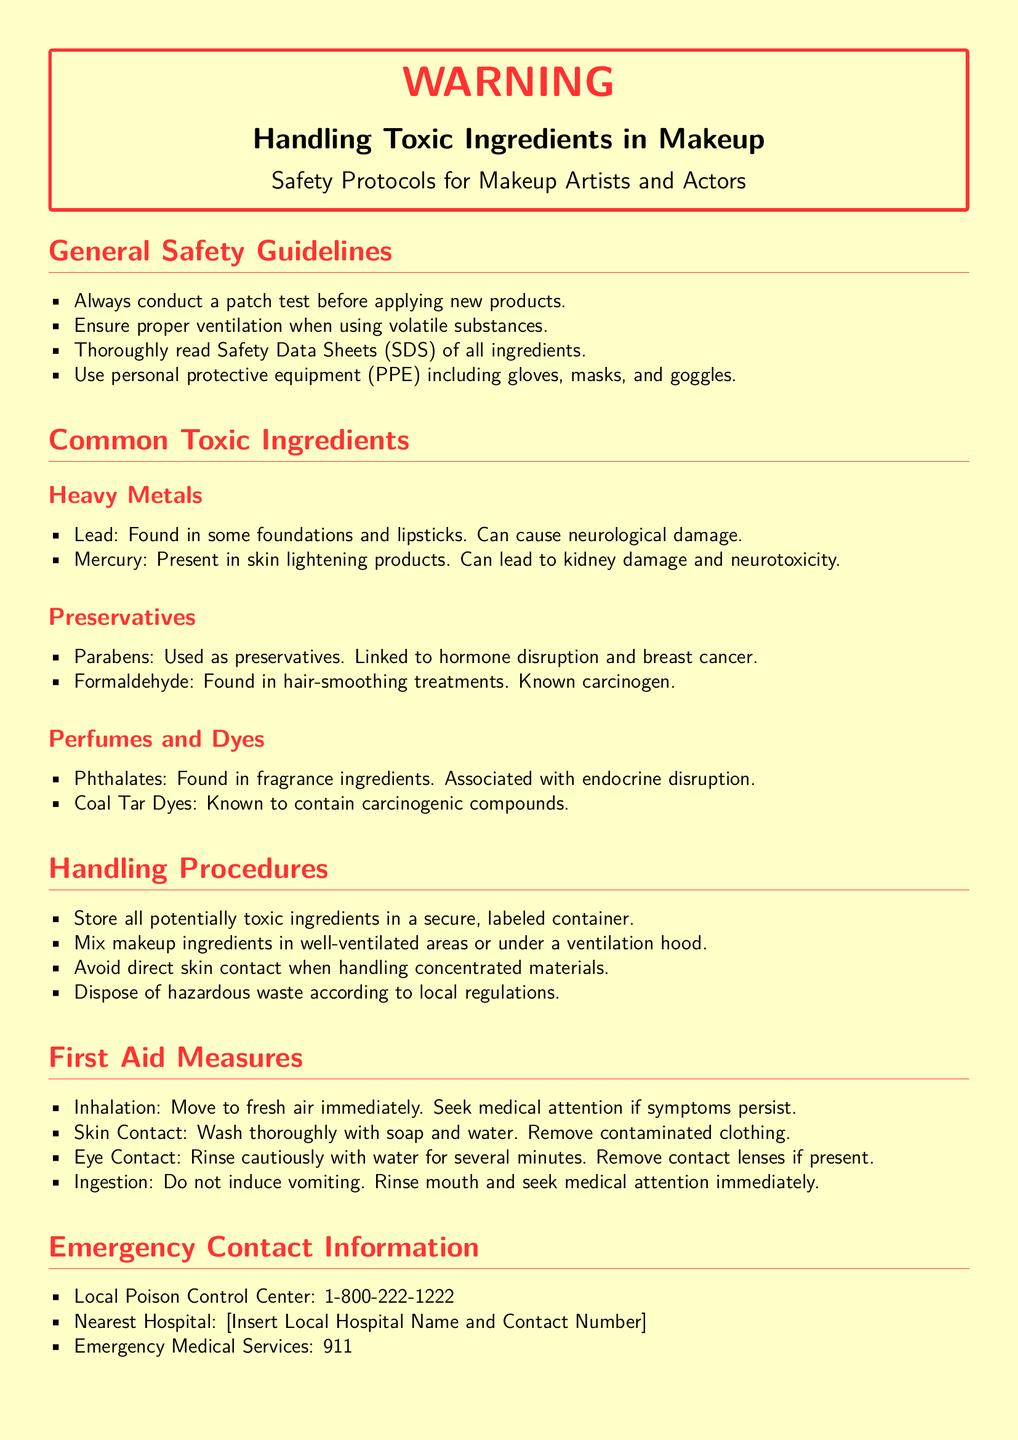What is the primary focus of the document? The document is a warning label providing safety protocols related to handling toxic ingredients in makeup.
Answer: Handling Toxic Ingredients in Makeup What type of personal protective equipment is recommended? The document suggests using personal protective equipment to ensure safety while handling toxic substances in makeup.
Answer: Gloves, masks, and goggles What should you do before applying new makeup products? The document states that a patch test should be conducted to prevent adverse reactions.
Answer: Conduct a patch test What is the main hazard associated with Lead? The document clearly outlines the neurological damage risk associated with Lead.
Answer: Neurological damage Which emergency number should be called for Poison Control? The document specifies contacting a Poison Control Center for assistance in case of exposure.
Answer: 1-800-222-1222 What type of environment is recommended for mixing makeup ingredients? The document emphasizes the need for proper ventilation while mixing potentially toxic makeup products.
Answer: Well-ventilated areas What should be done in case of eye contact with toxic ingredients? The document provides specific first aid measures for eye exposure, which include rinsing with water.
Answer: Rinse cautiously with water What should you do if someone ingests a toxic makeup ingredient? The document advises seeking medical attention immediately without inducing vomiting.
Answer: Seek medical attention immediately 